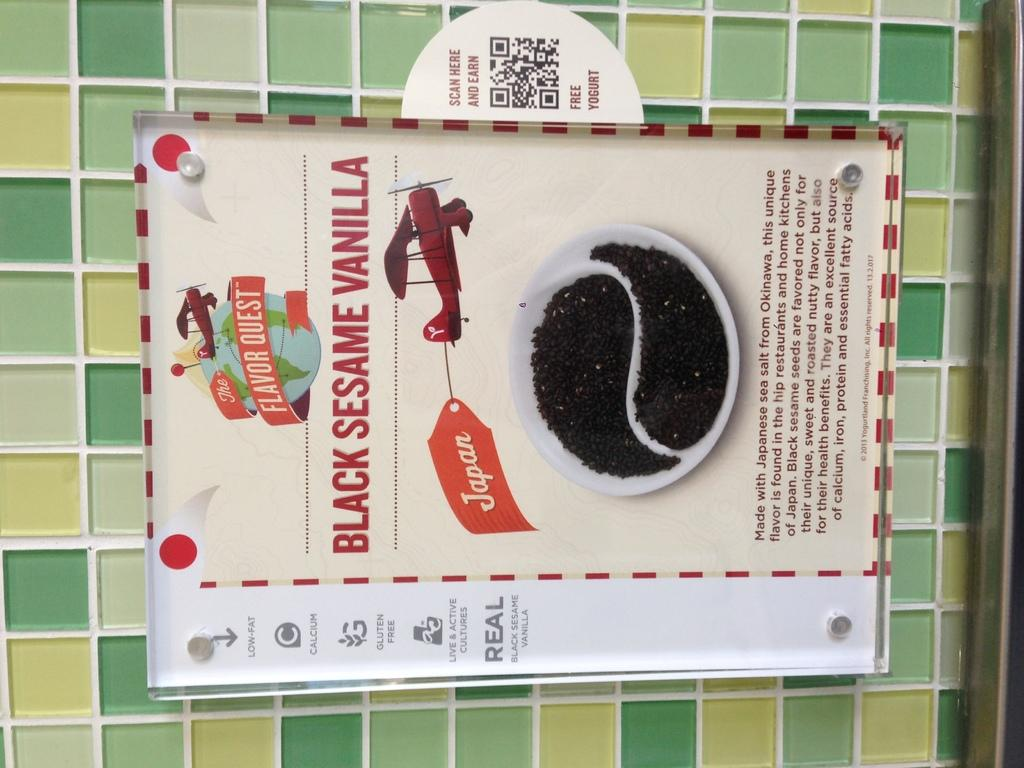Provide a one-sentence caption for the provided image. An advertisement for black sesame vanilla coffee grounds. 